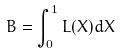Convert formula to latex. <formula><loc_0><loc_0><loc_500><loc_500>B = \int _ { 0 } ^ { 1 } L ( X ) d X</formula> 